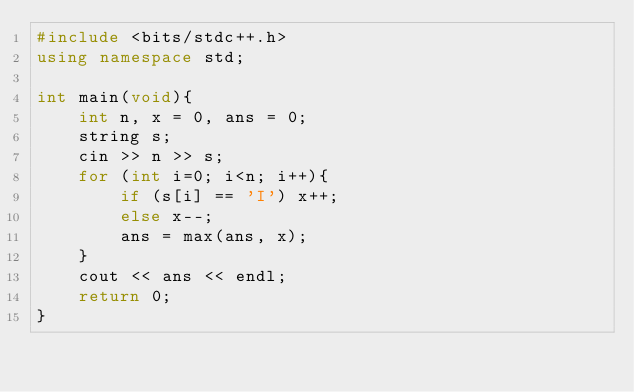<code> <loc_0><loc_0><loc_500><loc_500><_C++_>#include <bits/stdc++.h>
using namespace std;

int main(void){
    int n, x = 0, ans = 0;
    string s;
    cin >> n >> s;
    for (int i=0; i<n; i++){
        if (s[i] == 'I') x++;
        else x--;
        ans = max(ans, x);
    }
    cout << ans << endl;
    return 0;
}</code> 